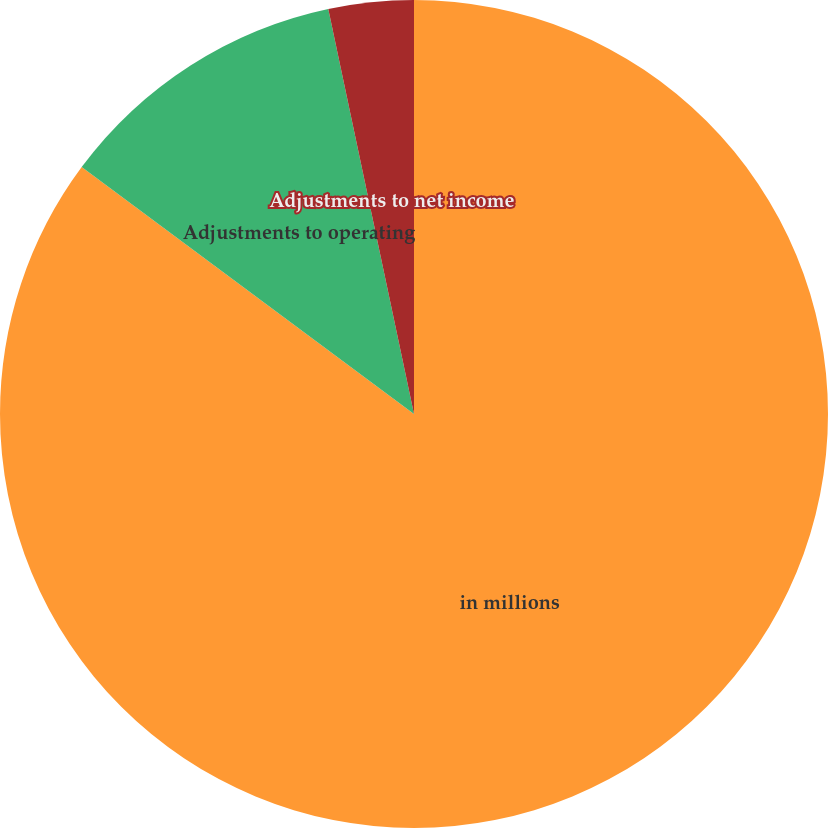Convert chart to OTSL. <chart><loc_0><loc_0><loc_500><loc_500><pie_chart><fcel>in millions<fcel>Adjustments to operating<fcel>Adjustments to net income<nl><fcel>85.17%<fcel>11.51%<fcel>3.32%<nl></chart> 